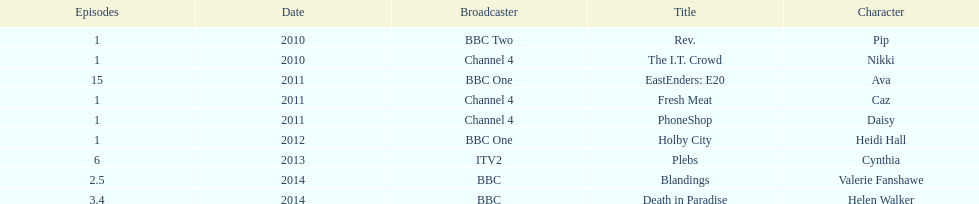Were there more than four episodes that featured cynthia? Yes. Could you help me parse every detail presented in this table? {'header': ['Episodes', 'Date', 'Broadcaster', 'Title', 'Character'], 'rows': [['1', '2010', 'BBC Two', 'Rev.', 'Pip'], ['1', '2010', 'Channel 4', 'The I.T. Crowd', 'Nikki'], ['15', '2011', 'BBC One', 'EastEnders: E20', 'Ava'], ['1', '2011', 'Channel 4', 'Fresh Meat', 'Caz'], ['1', '2011', 'Channel 4', 'PhoneShop', 'Daisy'], ['1', '2012', 'BBC One', 'Holby City', 'Heidi Hall'], ['6', '2013', 'ITV2', 'Plebs', 'Cynthia'], ['2.5', '2014', 'BBC', 'Blandings', 'Valerie Fanshawe'], ['3.4', '2014', 'BBC', 'Death in Paradise', 'Helen Walker']]} 